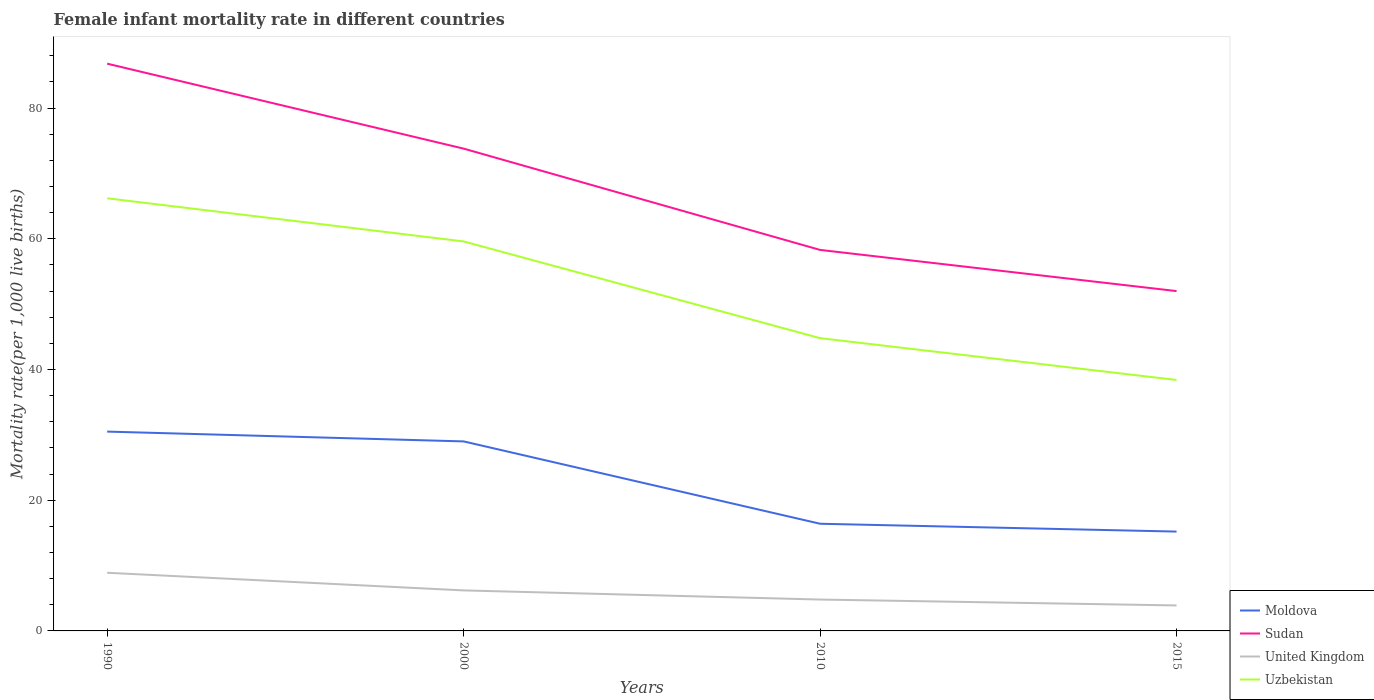How many different coloured lines are there?
Provide a short and direct response. 4. Does the line corresponding to Moldova intersect with the line corresponding to Sudan?
Offer a very short reply. No. Across all years, what is the maximum female infant mortality rate in Sudan?
Your response must be concise. 52. In which year was the female infant mortality rate in Sudan maximum?
Provide a short and direct response. 2015. What is the total female infant mortality rate in Uzbekistan in the graph?
Your answer should be very brief. 6.6. What is the difference between the highest and the second highest female infant mortality rate in Moldova?
Your answer should be compact. 15.3. Are the values on the major ticks of Y-axis written in scientific E-notation?
Your response must be concise. No. Does the graph contain any zero values?
Offer a terse response. No. Does the graph contain grids?
Ensure brevity in your answer.  No. What is the title of the graph?
Your answer should be compact. Female infant mortality rate in different countries. What is the label or title of the X-axis?
Offer a very short reply. Years. What is the label or title of the Y-axis?
Give a very brief answer. Mortality rate(per 1,0 live births). What is the Mortality rate(per 1,000 live births) of Moldova in 1990?
Ensure brevity in your answer.  30.5. What is the Mortality rate(per 1,000 live births) in Sudan in 1990?
Offer a very short reply. 86.8. What is the Mortality rate(per 1,000 live births) of Uzbekistan in 1990?
Provide a succinct answer. 66.2. What is the Mortality rate(per 1,000 live births) in Sudan in 2000?
Keep it short and to the point. 73.8. What is the Mortality rate(per 1,000 live births) in United Kingdom in 2000?
Your response must be concise. 6.2. What is the Mortality rate(per 1,000 live births) of Uzbekistan in 2000?
Keep it short and to the point. 59.6. What is the Mortality rate(per 1,000 live births) in Moldova in 2010?
Your response must be concise. 16.4. What is the Mortality rate(per 1,000 live births) of Sudan in 2010?
Offer a very short reply. 58.3. What is the Mortality rate(per 1,000 live births) of United Kingdom in 2010?
Your answer should be compact. 4.8. What is the Mortality rate(per 1,000 live births) in Uzbekistan in 2010?
Your answer should be very brief. 44.8. What is the Mortality rate(per 1,000 live births) of Moldova in 2015?
Your answer should be compact. 15.2. What is the Mortality rate(per 1,000 live births) in Sudan in 2015?
Your response must be concise. 52. What is the Mortality rate(per 1,000 live births) in United Kingdom in 2015?
Ensure brevity in your answer.  3.9. What is the Mortality rate(per 1,000 live births) in Uzbekistan in 2015?
Offer a very short reply. 38.4. Across all years, what is the maximum Mortality rate(per 1,000 live births) of Moldova?
Offer a very short reply. 30.5. Across all years, what is the maximum Mortality rate(per 1,000 live births) in Sudan?
Give a very brief answer. 86.8. Across all years, what is the maximum Mortality rate(per 1,000 live births) in Uzbekistan?
Give a very brief answer. 66.2. Across all years, what is the minimum Mortality rate(per 1,000 live births) of Moldova?
Offer a terse response. 15.2. Across all years, what is the minimum Mortality rate(per 1,000 live births) in Sudan?
Your answer should be very brief. 52. Across all years, what is the minimum Mortality rate(per 1,000 live births) of United Kingdom?
Keep it short and to the point. 3.9. Across all years, what is the minimum Mortality rate(per 1,000 live births) in Uzbekistan?
Your response must be concise. 38.4. What is the total Mortality rate(per 1,000 live births) in Moldova in the graph?
Give a very brief answer. 91.1. What is the total Mortality rate(per 1,000 live births) in Sudan in the graph?
Your response must be concise. 270.9. What is the total Mortality rate(per 1,000 live births) in United Kingdom in the graph?
Ensure brevity in your answer.  23.8. What is the total Mortality rate(per 1,000 live births) of Uzbekistan in the graph?
Keep it short and to the point. 209. What is the difference between the Mortality rate(per 1,000 live births) in Moldova in 1990 and that in 2000?
Provide a short and direct response. 1.5. What is the difference between the Mortality rate(per 1,000 live births) in Sudan in 1990 and that in 2010?
Provide a succinct answer. 28.5. What is the difference between the Mortality rate(per 1,000 live births) of Uzbekistan in 1990 and that in 2010?
Offer a terse response. 21.4. What is the difference between the Mortality rate(per 1,000 live births) of Sudan in 1990 and that in 2015?
Give a very brief answer. 34.8. What is the difference between the Mortality rate(per 1,000 live births) in United Kingdom in 1990 and that in 2015?
Provide a succinct answer. 5. What is the difference between the Mortality rate(per 1,000 live births) in Uzbekistan in 1990 and that in 2015?
Ensure brevity in your answer.  27.8. What is the difference between the Mortality rate(per 1,000 live births) in Moldova in 2000 and that in 2010?
Your answer should be very brief. 12.6. What is the difference between the Mortality rate(per 1,000 live births) in Sudan in 2000 and that in 2010?
Give a very brief answer. 15.5. What is the difference between the Mortality rate(per 1,000 live births) in Uzbekistan in 2000 and that in 2010?
Your answer should be compact. 14.8. What is the difference between the Mortality rate(per 1,000 live births) of Sudan in 2000 and that in 2015?
Offer a terse response. 21.8. What is the difference between the Mortality rate(per 1,000 live births) of United Kingdom in 2000 and that in 2015?
Ensure brevity in your answer.  2.3. What is the difference between the Mortality rate(per 1,000 live births) of Uzbekistan in 2000 and that in 2015?
Offer a very short reply. 21.2. What is the difference between the Mortality rate(per 1,000 live births) in Moldova in 1990 and the Mortality rate(per 1,000 live births) in Sudan in 2000?
Offer a very short reply. -43.3. What is the difference between the Mortality rate(per 1,000 live births) in Moldova in 1990 and the Mortality rate(per 1,000 live births) in United Kingdom in 2000?
Your answer should be compact. 24.3. What is the difference between the Mortality rate(per 1,000 live births) of Moldova in 1990 and the Mortality rate(per 1,000 live births) of Uzbekistan in 2000?
Provide a short and direct response. -29.1. What is the difference between the Mortality rate(per 1,000 live births) of Sudan in 1990 and the Mortality rate(per 1,000 live births) of United Kingdom in 2000?
Ensure brevity in your answer.  80.6. What is the difference between the Mortality rate(per 1,000 live births) of Sudan in 1990 and the Mortality rate(per 1,000 live births) of Uzbekistan in 2000?
Ensure brevity in your answer.  27.2. What is the difference between the Mortality rate(per 1,000 live births) of United Kingdom in 1990 and the Mortality rate(per 1,000 live births) of Uzbekistan in 2000?
Provide a succinct answer. -50.7. What is the difference between the Mortality rate(per 1,000 live births) in Moldova in 1990 and the Mortality rate(per 1,000 live births) in Sudan in 2010?
Offer a terse response. -27.8. What is the difference between the Mortality rate(per 1,000 live births) in Moldova in 1990 and the Mortality rate(per 1,000 live births) in United Kingdom in 2010?
Offer a terse response. 25.7. What is the difference between the Mortality rate(per 1,000 live births) in Moldova in 1990 and the Mortality rate(per 1,000 live births) in Uzbekistan in 2010?
Your answer should be compact. -14.3. What is the difference between the Mortality rate(per 1,000 live births) in United Kingdom in 1990 and the Mortality rate(per 1,000 live births) in Uzbekistan in 2010?
Offer a terse response. -35.9. What is the difference between the Mortality rate(per 1,000 live births) in Moldova in 1990 and the Mortality rate(per 1,000 live births) in Sudan in 2015?
Offer a terse response. -21.5. What is the difference between the Mortality rate(per 1,000 live births) of Moldova in 1990 and the Mortality rate(per 1,000 live births) of United Kingdom in 2015?
Offer a very short reply. 26.6. What is the difference between the Mortality rate(per 1,000 live births) in Sudan in 1990 and the Mortality rate(per 1,000 live births) in United Kingdom in 2015?
Give a very brief answer. 82.9. What is the difference between the Mortality rate(per 1,000 live births) of Sudan in 1990 and the Mortality rate(per 1,000 live births) of Uzbekistan in 2015?
Your response must be concise. 48.4. What is the difference between the Mortality rate(per 1,000 live births) in United Kingdom in 1990 and the Mortality rate(per 1,000 live births) in Uzbekistan in 2015?
Give a very brief answer. -29.5. What is the difference between the Mortality rate(per 1,000 live births) of Moldova in 2000 and the Mortality rate(per 1,000 live births) of Sudan in 2010?
Make the answer very short. -29.3. What is the difference between the Mortality rate(per 1,000 live births) in Moldova in 2000 and the Mortality rate(per 1,000 live births) in United Kingdom in 2010?
Keep it short and to the point. 24.2. What is the difference between the Mortality rate(per 1,000 live births) in Moldova in 2000 and the Mortality rate(per 1,000 live births) in Uzbekistan in 2010?
Ensure brevity in your answer.  -15.8. What is the difference between the Mortality rate(per 1,000 live births) of Sudan in 2000 and the Mortality rate(per 1,000 live births) of Uzbekistan in 2010?
Provide a succinct answer. 29. What is the difference between the Mortality rate(per 1,000 live births) in United Kingdom in 2000 and the Mortality rate(per 1,000 live births) in Uzbekistan in 2010?
Provide a succinct answer. -38.6. What is the difference between the Mortality rate(per 1,000 live births) in Moldova in 2000 and the Mortality rate(per 1,000 live births) in Sudan in 2015?
Offer a terse response. -23. What is the difference between the Mortality rate(per 1,000 live births) in Moldova in 2000 and the Mortality rate(per 1,000 live births) in United Kingdom in 2015?
Provide a succinct answer. 25.1. What is the difference between the Mortality rate(per 1,000 live births) in Moldova in 2000 and the Mortality rate(per 1,000 live births) in Uzbekistan in 2015?
Provide a short and direct response. -9.4. What is the difference between the Mortality rate(per 1,000 live births) of Sudan in 2000 and the Mortality rate(per 1,000 live births) of United Kingdom in 2015?
Provide a short and direct response. 69.9. What is the difference between the Mortality rate(per 1,000 live births) of Sudan in 2000 and the Mortality rate(per 1,000 live births) of Uzbekistan in 2015?
Offer a very short reply. 35.4. What is the difference between the Mortality rate(per 1,000 live births) in United Kingdom in 2000 and the Mortality rate(per 1,000 live births) in Uzbekistan in 2015?
Give a very brief answer. -32.2. What is the difference between the Mortality rate(per 1,000 live births) in Moldova in 2010 and the Mortality rate(per 1,000 live births) in Sudan in 2015?
Your answer should be very brief. -35.6. What is the difference between the Mortality rate(per 1,000 live births) in Moldova in 2010 and the Mortality rate(per 1,000 live births) in Uzbekistan in 2015?
Your answer should be compact. -22. What is the difference between the Mortality rate(per 1,000 live births) of Sudan in 2010 and the Mortality rate(per 1,000 live births) of United Kingdom in 2015?
Keep it short and to the point. 54.4. What is the difference between the Mortality rate(per 1,000 live births) of United Kingdom in 2010 and the Mortality rate(per 1,000 live births) of Uzbekistan in 2015?
Give a very brief answer. -33.6. What is the average Mortality rate(per 1,000 live births) of Moldova per year?
Keep it short and to the point. 22.77. What is the average Mortality rate(per 1,000 live births) of Sudan per year?
Offer a very short reply. 67.72. What is the average Mortality rate(per 1,000 live births) of United Kingdom per year?
Offer a very short reply. 5.95. What is the average Mortality rate(per 1,000 live births) in Uzbekistan per year?
Your answer should be very brief. 52.25. In the year 1990, what is the difference between the Mortality rate(per 1,000 live births) in Moldova and Mortality rate(per 1,000 live births) in Sudan?
Your answer should be very brief. -56.3. In the year 1990, what is the difference between the Mortality rate(per 1,000 live births) in Moldova and Mortality rate(per 1,000 live births) in United Kingdom?
Offer a terse response. 21.6. In the year 1990, what is the difference between the Mortality rate(per 1,000 live births) in Moldova and Mortality rate(per 1,000 live births) in Uzbekistan?
Your response must be concise. -35.7. In the year 1990, what is the difference between the Mortality rate(per 1,000 live births) of Sudan and Mortality rate(per 1,000 live births) of United Kingdom?
Keep it short and to the point. 77.9. In the year 1990, what is the difference between the Mortality rate(per 1,000 live births) of Sudan and Mortality rate(per 1,000 live births) of Uzbekistan?
Your response must be concise. 20.6. In the year 1990, what is the difference between the Mortality rate(per 1,000 live births) of United Kingdom and Mortality rate(per 1,000 live births) of Uzbekistan?
Offer a terse response. -57.3. In the year 2000, what is the difference between the Mortality rate(per 1,000 live births) in Moldova and Mortality rate(per 1,000 live births) in Sudan?
Give a very brief answer. -44.8. In the year 2000, what is the difference between the Mortality rate(per 1,000 live births) in Moldova and Mortality rate(per 1,000 live births) in United Kingdom?
Your response must be concise. 22.8. In the year 2000, what is the difference between the Mortality rate(per 1,000 live births) in Moldova and Mortality rate(per 1,000 live births) in Uzbekistan?
Offer a terse response. -30.6. In the year 2000, what is the difference between the Mortality rate(per 1,000 live births) in Sudan and Mortality rate(per 1,000 live births) in United Kingdom?
Your answer should be compact. 67.6. In the year 2000, what is the difference between the Mortality rate(per 1,000 live births) of Sudan and Mortality rate(per 1,000 live births) of Uzbekistan?
Offer a very short reply. 14.2. In the year 2000, what is the difference between the Mortality rate(per 1,000 live births) in United Kingdom and Mortality rate(per 1,000 live births) in Uzbekistan?
Provide a short and direct response. -53.4. In the year 2010, what is the difference between the Mortality rate(per 1,000 live births) of Moldova and Mortality rate(per 1,000 live births) of Sudan?
Your response must be concise. -41.9. In the year 2010, what is the difference between the Mortality rate(per 1,000 live births) in Moldova and Mortality rate(per 1,000 live births) in Uzbekistan?
Your answer should be compact. -28.4. In the year 2010, what is the difference between the Mortality rate(per 1,000 live births) in Sudan and Mortality rate(per 1,000 live births) in United Kingdom?
Your response must be concise. 53.5. In the year 2010, what is the difference between the Mortality rate(per 1,000 live births) in Sudan and Mortality rate(per 1,000 live births) in Uzbekistan?
Provide a succinct answer. 13.5. In the year 2015, what is the difference between the Mortality rate(per 1,000 live births) in Moldova and Mortality rate(per 1,000 live births) in Sudan?
Ensure brevity in your answer.  -36.8. In the year 2015, what is the difference between the Mortality rate(per 1,000 live births) of Moldova and Mortality rate(per 1,000 live births) of Uzbekistan?
Ensure brevity in your answer.  -23.2. In the year 2015, what is the difference between the Mortality rate(per 1,000 live births) of Sudan and Mortality rate(per 1,000 live births) of United Kingdom?
Your response must be concise. 48.1. In the year 2015, what is the difference between the Mortality rate(per 1,000 live births) of Sudan and Mortality rate(per 1,000 live births) of Uzbekistan?
Make the answer very short. 13.6. In the year 2015, what is the difference between the Mortality rate(per 1,000 live births) of United Kingdom and Mortality rate(per 1,000 live births) of Uzbekistan?
Provide a succinct answer. -34.5. What is the ratio of the Mortality rate(per 1,000 live births) in Moldova in 1990 to that in 2000?
Offer a very short reply. 1.05. What is the ratio of the Mortality rate(per 1,000 live births) of Sudan in 1990 to that in 2000?
Your answer should be very brief. 1.18. What is the ratio of the Mortality rate(per 1,000 live births) of United Kingdom in 1990 to that in 2000?
Give a very brief answer. 1.44. What is the ratio of the Mortality rate(per 1,000 live births) in Uzbekistan in 1990 to that in 2000?
Offer a terse response. 1.11. What is the ratio of the Mortality rate(per 1,000 live births) in Moldova in 1990 to that in 2010?
Your response must be concise. 1.86. What is the ratio of the Mortality rate(per 1,000 live births) in Sudan in 1990 to that in 2010?
Keep it short and to the point. 1.49. What is the ratio of the Mortality rate(per 1,000 live births) in United Kingdom in 1990 to that in 2010?
Provide a succinct answer. 1.85. What is the ratio of the Mortality rate(per 1,000 live births) in Uzbekistan in 1990 to that in 2010?
Make the answer very short. 1.48. What is the ratio of the Mortality rate(per 1,000 live births) in Moldova in 1990 to that in 2015?
Provide a short and direct response. 2.01. What is the ratio of the Mortality rate(per 1,000 live births) in Sudan in 1990 to that in 2015?
Offer a terse response. 1.67. What is the ratio of the Mortality rate(per 1,000 live births) of United Kingdom in 1990 to that in 2015?
Offer a very short reply. 2.28. What is the ratio of the Mortality rate(per 1,000 live births) of Uzbekistan in 1990 to that in 2015?
Provide a succinct answer. 1.72. What is the ratio of the Mortality rate(per 1,000 live births) of Moldova in 2000 to that in 2010?
Your answer should be very brief. 1.77. What is the ratio of the Mortality rate(per 1,000 live births) of Sudan in 2000 to that in 2010?
Your answer should be compact. 1.27. What is the ratio of the Mortality rate(per 1,000 live births) in United Kingdom in 2000 to that in 2010?
Your response must be concise. 1.29. What is the ratio of the Mortality rate(per 1,000 live births) in Uzbekistan in 2000 to that in 2010?
Your answer should be very brief. 1.33. What is the ratio of the Mortality rate(per 1,000 live births) of Moldova in 2000 to that in 2015?
Provide a succinct answer. 1.91. What is the ratio of the Mortality rate(per 1,000 live births) in Sudan in 2000 to that in 2015?
Offer a terse response. 1.42. What is the ratio of the Mortality rate(per 1,000 live births) of United Kingdom in 2000 to that in 2015?
Make the answer very short. 1.59. What is the ratio of the Mortality rate(per 1,000 live births) in Uzbekistan in 2000 to that in 2015?
Make the answer very short. 1.55. What is the ratio of the Mortality rate(per 1,000 live births) of Moldova in 2010 to that in 2015?
Provide a succinct answer. 1.08. What is the ratio of the Mortality rate(per 1,000 live births) in Sudan in 2010 to that in 2015?
Make the answer very short. 1.12. What is the ratio of the Mortality rate(per 1,000 live births) in United Kingdom in 2010 to that in 2015?
Your answer should be compact. 1.23. What is the difference between the highest and the second highest Mortality rate(per 1,000 live births) in United Kingdom?
Your response must be concise. 2.7. What is the difference between the highest and the second highest Mortality rate(per 1,000 live births) in Uzbekistan?
Ensure brevity in your answer.  6.6. What is the difference between the highest and the lowest Mortality rate(per 1,000 live births) of Sudan?
Your answer should be compact. 34.8. What is the difference between the highest and the lowest Mortality rate(per 1,000 live births) in United Kingdom?
Offer a terse response. 5. What is the difference between the highest and the lowest Mortality rate(per 1,000 live births) of Uzbekistan?
Provide a succinct answer. 27.8. 